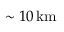<formula> <loc_0><loc_0><loc_500><loc_500>\sim 1 0 \, k m</formula> 